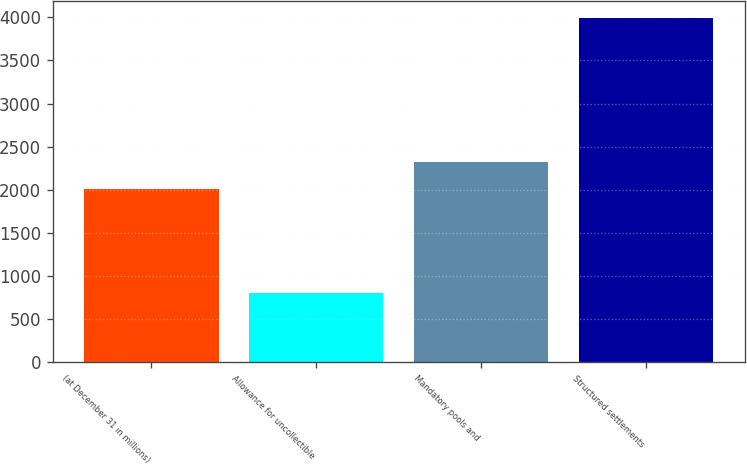Convert chart to OTSL. <chart><loc_0><loc_0><loc_500><loc_500><bar_chart><fcel>(at December 31 in millions)<fcel>Allowance for uncollectible<fcel>Mandatory pools and<fcel>Structured settlements<nl><fcel>2005<fcel>804<fcel>2323.6<fcel>3990<nl></chart> 